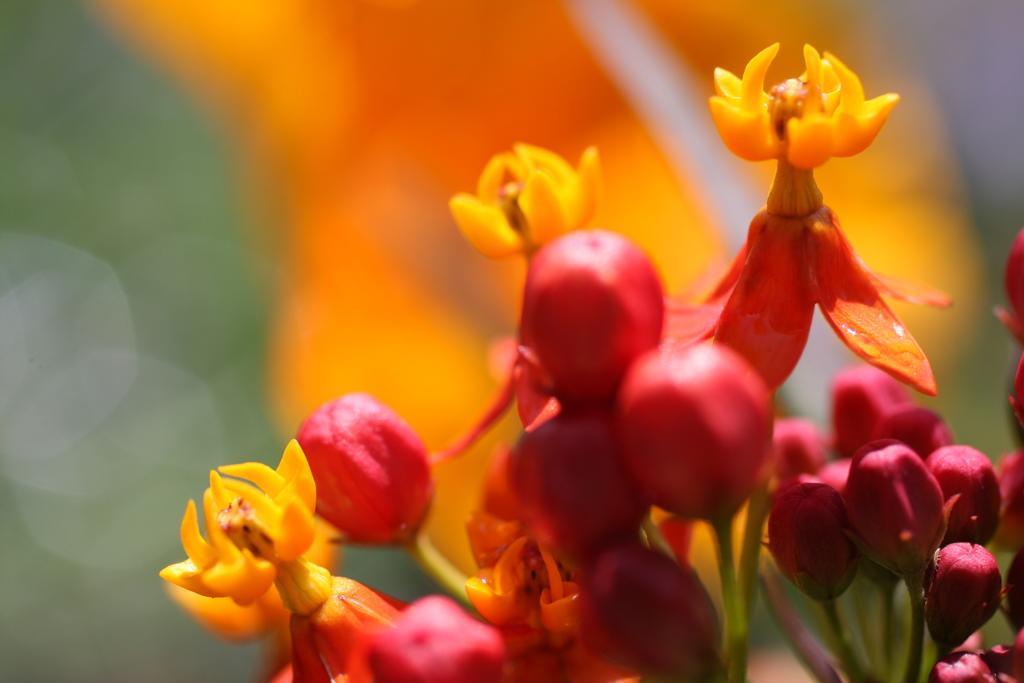Describe this image in one or two sentences. This picture seems be of outside. On the right there is a plant and we can see the flowers and buds of the plant. The background is orange in color and on the left we can see the green color background. 